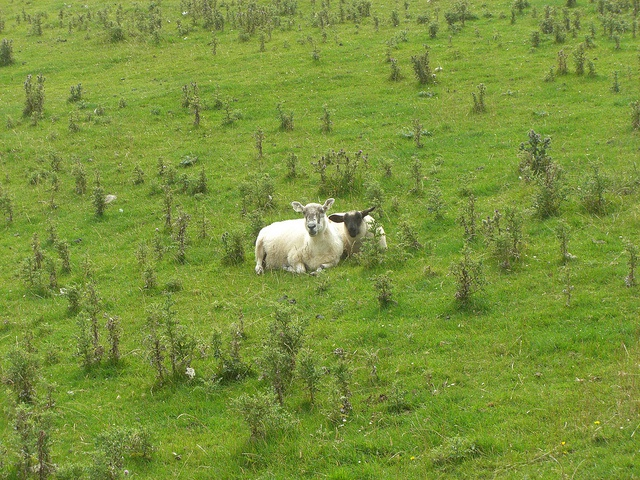Describe the objects in this image and their specific colors. I can see sheep in olive, ivory, tan, and beige tones and sheep in olive, darkgreen, gray, and ivory tones in this image. 